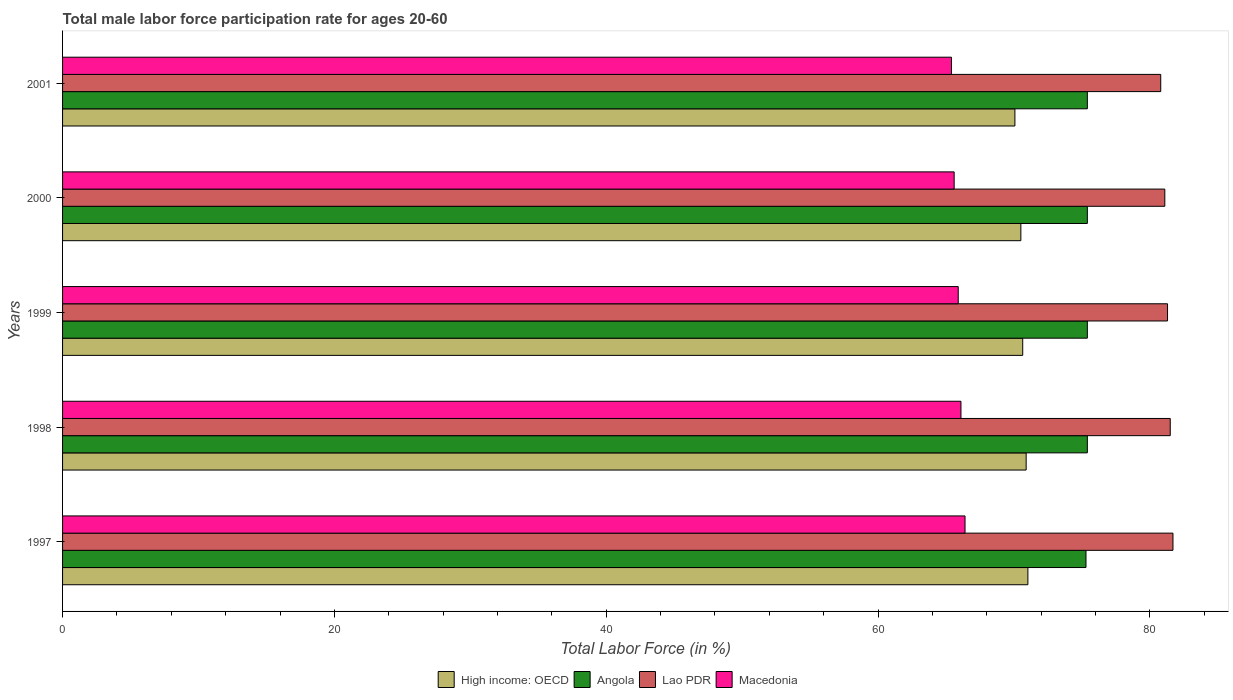How many different coloured bars are there?
Offer a terse response. 4. How many groups of bars are there?
Provide a short and direct response. 5. How many bars are there on the 4th tick from the top?
Provide a short and direct response. 4. What is the label of the 3rd group of bars from the top?
Ensure brevity in your answer.  1999. In how many cases, is the number of bars for a given year not equal to the number of legend labels?
Offer a very short reply. 0. What is the male labor force participation rate in High income: OECD in 2001?
Your answer should be compact. 70.07. Across all years, what is the maximum male labor force participation rate in Macedonia?
Your answer should be very brief. 66.4. Across all years, what is the minimum male labor force participation rate in Macedonia?
Keep it short and to the point. 65.4. In which year was the male labor force participation rate in Lao PDR maximum?
Provide a short and direct response. 1997. What is the total male labor force participation rate in Macedonia in the graph?
Make the answer very short. 329.4. What is the difference between the male labor force participation rate in Lao PDR in 1998 and that in 1999?
Your answer should be very brief. 0.2. What is the difference between the male labor force participation rate in Angola in 2000 and the male labor force participation rate in Macedonia in 1997?
Offer a very short reply. 9. What is the average male labor force participation rate in Macedonia per year?
Keep it short and to the point. 65.88. In the year 1999, what is the difference between the male labor force participation rate in High income: OECD and male labor force participation rate in Angola?
Make the answer very short. -4.76. In how many years, is the male labor force participation rate in Lao PDR greater than 68 %?
Offer a very short reply. 5. What is the ratio of the male labor force participation rate in Lao PDR in 1998 to that in 1999?
Offer a very short reply. 1. What is the difference between the highest and the second highest male labor force participation rate in High income: OECD?
Offer a terse response. 0.13. What is the difference between the highest and the lowest male labor force participation rate in Macedonia?
Make the answer very short. 1. In how many years, is the male labor force participation rate in Angola greater than the average male labor force participation rate in Angola taken over all years?
Provide a succinct answer. 4. What does the 4th bar from the top in 2000 represents?
Your answer should be compact. High income: OECD. What does the 3rd bar from the bottom in 1999 represents?
Keep it short and to the point. Lao PDR. How many bars are there?
Your answer should be very brief. 20. How many years are there in the graph?
Offer a terse response. 5. Are the values on the major ticks of X-axis written in scientific E-notation?
Your answer should be very brief. No. Does the graph contain grids?
Your answer should be compact. No. Where does the legend appear in the graph?
Keep it short and to the point. Bottom center. What is the title of the graph?
Your answer should be very brief. Total male labor force participation rate for ages 20-60. What is the label or title of the Y-axis?
Your response must be concise. Years. What is the Total Labor Force (in %) of High income: OECD in 1997?
Provide a short and direct response. 71.03. What is the Total Labor Force (in %) in Angola in 1997?
Your response must be concise. 75.3. What is the Total Labor Force (in %) in Lao PDR in 1997?
Provide a succinct answer. 81.7. What is the Total Labor Force (in %) of Macedonia in 1997?
Make the answer very short. 66.4. What is the Total Labor Force (in %) of High income: OECD in 1998?
Offer a terse response. 70.9. What is the Total Labor Force (in %) of Angola in 1998?
Offer a terse response. 75.4. What is the Total Labor Force (in %) of Lao PDR in 1998?
Ensure brevity in your answer.  81.5. What is the Total Labor Force (in %) of Macedonia in 1998?
Provide a short and direct response. 66.1. What is the Total Labor Force (in %) of High income: OECD in 1999?
Give a very brief answer. 70.64. What is the Total Labor Force (in %) of Angola in 1999?
Make the answer very short. 75.4. What is the Total Labor Force (in %) of Lao PDR in 1999?
Provide a succinct answer. 81.3. What is the Total Labor Force (in %) of Macedonia in 1999?
Provide a succinct answer. 65.9. What is the Total Labor Force (in %) in High income: OECD in 2000?
Provide a short and direct response. 70.51. What is the Total Labor Force (in %) in Angola in 2000?
Offer a very short reply. 75.4. What is the Total Labor Force (in %) of Lao PDR in 2000?
Your response must be concise. 81.1. What is the Total Labor Force (in %) in Macedonia in 2000?
Your answer should be very brief. 65.6. What is the Total Labor Force (in %) in High income: OECD in 2001?
Make the answer very short. 70.07. What is the Total Labor Force (in %) of Angola in 2001?
Provide a short and direct response. 75.4. What is the Total Labor Force (in %) in Lao PDR in 2001?
Give a very brief answer. 80.8. What is the Total Labor Force (in %) in Macedonia in 2001?
Provide a succinct answer. 65.4. Across all years, what is the maximum Total Labor Force (in %) of High income: OECD?
Keep it short and to the point. 71.03. Across all years, what is the maximum Total Labor Force (in %) in Angola?
Your response must be concise. 75.4. Across all years, what is the maximum Total Labor Force (in %) in Lao PDR?
Ensure brevity in your answer.  81.7. Across all years, what is the maximum Total Labor Force (in %) in Macedonia?
Make the answer very short. 66.4. Across all years, what is the minimum Total Labor Force (in %) in High income: OECD?
Your response must be concise. 70.07. Across all years, what is the minimum Total Labor Force (in %) of Angola?
Your response must be concise. 75.3. Across all years, what is the minimum Total Labor Force (in %) in Lao PDR?
Keep it short and to the point. 80.8. Across all years, what is the minimum Total Labor Force (in %) of Macedonia?
Provide a short and direct response. 65.4. What is the total Total Labor Force (in %) in High income: OECD in the graph?
Provide a succinct answer. 353.15. What is the total Total Labor Force (in %) of Angola in the graph?
Your answer should be very brief. 376.9. What is the total Total Labor Force (in %) of Lao PDR in the graph?
Ensure brevity in your answer.  406.4. What is the total Total Labor Force (in %) of Macedonia in the graph?
Provide a short and direct response. 329.4. What is the difference between the Total Labor Force (in %) in High income: OECD in 1997 and that in 1998?
Keep it short and to the point. 0.13. What is the difference between the Total Labor Force (in %) in Macedonia in 1997 and that in 1998?
Offer a terse response. 0.3. What is the difference between the Total Labor Force (in %) of High income: OECD in 1997 and that in 1999?
Keep it short and to the point. 0.38. What is the difference between the Total Labor Force (in %) in Macedonia in 1997 and that in 1999?
Offer a very short reply. 0.5. What is the difference between the Total Labor Force (in %) of High income: OECD in 1997 and that in 2000?
Make the answer very short. 0.52. What is the difference between the Total Labor Force (in %) of Angola in 1997 and that in 2000?
Your answer should be very brief. -0.1. What is the difference between the Total Labor Force (in %) of Lao PDR in 1997 and that in 2000?
Give a very brief answer. 0.6. What is the difference between the Total Labor Force (in %) in Macedonia in 1997 and that in 2000?
Ensure brevity in your answer.  0.8. What is the difference between the Total Labor Force (in %) of High income: OECD in 1997 and that in 2001?
Your response must be concise. 0.96. What is the difference between the Total Labor Force (in %) in Lao PDR in 1997 and that in 2001?
Your answer should be very brief. 0.9. What is the difference between the Total Labor Force (in %) in Macedonia in 1997 and that in 2001?
Provide a succinct answer. 1. What is the difference between the Total Labor Force (in %) in High income: OECD in 1998 and that in 1999?
Your answer should be compact. 0.25. What is the difference between the Total Labor Force (in %) in Angola in 1998 and that in 1999?
Offer a terse response. 0. What is the difference between the Total Labor Force (in %) of Lao PDR in 1998 and that in 1999?
Offer a very short reply. 0.2. What is the difference between the Total Labor Force (in %) of High income: OECD in 1998 and that in 2000?
Provide a succinct answer. 0.39. What is the difference between the Total Labor Force (in %) of Lao PDR in 1998 and that in 2000?
Provide a short and direct response. 0.4. What is the difference between the Total Labor Force (in %) in Macedonia in 1998 and that in 2000?
Give a very brief answer. 0.5. What is the difference between the Total Labor Force (in %) of High income: OECD in 1998 and that in 2001?
Keep it short and to the point. 0.83. What is the difference between the Total Labor Force (in %) in Lao PDR in 1998 and that in 2001?
Your answer should be compact. 0.7. What is the difference between the Total Labor Force (in %) in Macedonia in 1998 and that in 2001?
Give a very brief answer. 0.7. What is the difference between the Total Labor Force (in %) of High income: OECD in 1999 and that in 2000?
Provide a short and direct response. 0.14. What is the difference between the Total Labor Force (in %) of Angola in 1999 and that in 2000?
Your answer should be very brief. 0. What is the difference between the Total Labor Force (in %) of Macedonia in 1999 and that in 2000?
Offer a terse response. 0.3. What is the difference between the Total Labor Force (in %) of High income: OECD in 1999 and that in 2001?
Make the answer very short. 0.57. What is the difference between the Total Labor Force (in %) of Angola in 1999 and that in 2001?
Give a very brief answer. 0. What is the difference between the Total Labor Force (in %) of Lao PDR in 1999 and that in 2001?
Your answer should be compact. 0.5. What is the difference between the Total Labor Force (in %) in High income: OECD in 2000 and that in 2001?
Give a very brief answer. 0.44. What is the difference between the Total Labor Force (in %) of Angola in 2000 and that in 2001?
Ensure brevity in your answer.  0. What is the difference between the Total Labor Force (in %) of High income: OECD in 1997 and the Total Labor Force (in %) of Angola in 1998?
Keep it short and to the point. -4.37. What is the difference between the Total Labor Force (in %) of High income: OECD in 1997 and the Total Labor Force (in %) of Lao PDR in 1998?
Offer a terse response. -10.47. What is the difference between the Total Labor Force (in %) of High income: OECD in 1997 and the Total Labor Force (in %) of Macedonia in 1998?
Give a very brief answer. 4.93. What is the difference between the Total Labor Force (in %) of Angola in 1997 and the Total Labor Force (in %) of Lao PDR in 1998?
Keep it short and to the point. -6.2. What is the difference between the Total Labor Force (in %) of High income: OECD in 1997 and the Total Labor Force (in %) of Angola in 1999?
Ensure brevity in your answer.  -4.37. What is the difference between the Total Labor Force (in %) in High income: OECD in 1997 and the Total Labor Force (in %) in Lao PDR in 1999?
Ensure brevity in your answer.  -10.27. What is the difference between the Total Labor Force (in %) of High income: OECD in 1997 and the Total Labor Force (in %) of Macedonia in 1999?
Provide a succinct answer. 5.13. What is the difference between the Total Labor Force (in %) in Angola in 1997 and the Total Labor Force (in %) in Lao PDR in 1999?
Make the answer very short. -6. What is the difference between the Total Labor Force (in %) of Angola in 1997 and the Total Labor Force (in %) of Macedonia in 1999?
Offer a very short reply. 9.4. What is the difference between the Total Labor Force (in %) in High income: OECD in 1997 and the Total Labor Force (in %) in Angola in 2000?
Make the answer very short. -4.37. What is the difference between the Total Labor Force (in %) in High income: OECD in 1997 and the Total Labor Force (in %) in Lao PDR in 2000?
Provide a succinct answer. -10.07. What is the difference between the Total Labor Force (in %) in High income: OECD in 1997 and the Total Labor Force (in %) in Macedonia in 2000?
Provide a short and direct response. 5.43. What is the difference between the Total Labor Force (in %) in Angola in 1997 and the Total Labor Force (in %) in Macedonia in 2000?
Keep it short and to the point. 9.7. What is the difference between the Total Labor Force (in %) of High income: OECD in 1997 and the Total Labor Force (in %) of Angola in 2001?
Keep it short and to the point. -4.37. What is the difference between the Total Labor Force (in %) in High income: OECD in 1997 and the Total Labor Force (in %) in Lao PDR in 2001?
Ensure brevity in your answer.  -9.77. What is the difference between the Total Labor Force (in %) of High income: OECD in 1997 and the Total Labor Force (in %) of Macedonia in 2001?
Your response must be concise. 5.63. What is the difference between the Total Labor Force (in %) of Angola in 1997 and the Total Labor Force (in %) of Lao PDR in 2001?
Your response must be concise. -5.5. What is the difference between the Total Labor Force (in %) of Angola in 1997 and the Total Labor Force (in %) of Macedonia in 2001?
Make the answer very short. 9.9. What is the difference between the Total Labor Force (in %) of Lao PDR in 1997 and the Total Labor Force (in %) of Macedonia in 2001?
Offer a very short reply. 16.3. What is the difference between the Total Labor Force (in %) in High income: OECD in 1998 and the Total Labor Force (in %) in Angola in 1999?
Offer a terse response. -4.5. What is the difference between the Total Labor Force (in %) in High income: OECD in 1998 and the Total Labor Force (in %) in Lao PDR in 1999?
Offer a terse response. -10.4. What is the difference between the Total Labor Force (in %) in High income: OECD in 1998 and the Total Labor Force (in %) in Macedonia in 1999?
Ensure brevity in your answer.  5. What is the difference between the Total Labor Force (in %) in Angola in 1998 and the Total Labor Force (in %) in Lao PDR in 1999?
Provide a succinct answer. -5.9. What is the difference between the Total Labor Force (in %) of High income: OECD in 1998 and the Total Labor Force (in %) of Angola in 2000?
Provide a short and direct response. -4.5. What is the difference between the Total Labor Force (in %) in High income: OECD in 1998 and the Total Labor Force (in %) in Lao PDR in 2000?
Your answer should be compact. -10.2. What is the difference between the Total Labor Force (in %) in High income: OECD in 1998 and the Total Labor Force (in %) in Macedonia in 2000?
Provide a succinct answer. 5.3. What is the difference between the Total Labor Force (in %) of Angola in 1998 and the Total Labor Force (in %) of Lao PDR in 2000?
Your response must be concise. -5.7. What is the difference between the Total Labor Force (in %) of High income: OECD in 1998 and the Total Labor Force (in %) of Angola in 2001?
Provide a short and direct response. -4.5. What is the difference between the Total Labor Force (in %) in High income: OECD in 1998 and the Total Labor Force (in %) in Lao PDR in 2001?
Offer a very short reply. -9.9. What is the difference between the Total Labor Force (in %) in High income: OECD in 1998 and the Total Labor Force (in %) in Macedonia in 2001?
Your answer should be compact. 5.5. What is the difference between the Total Labor Force (in %) of Angola in 1998 and the Total Labor Force (in %) of Lao PDR in 2001?
Keep it short and to the point. -5.4. What is the difference between the Total Labor Force (in %) of Angola in 1998 and the Total Labor Force (in %) of Macedonia in 2001?
Your answer should be compact. 10. What is the difference between the Total Labor Force (in %) of High income: OECD in 1999 and the Total Labor Force (in %) of Angola in 2000?
Your answer should be compact. -4.76. What is the difference between the Total Labor Force (in %) in High income: OECD in 1999 and the Total Labor Force (in %) in Lao PDR in 2000?
Provide a short and direct response. -10.46. What is the difference between the Total Labor Force (in %) of High income: OECD in 1999 and the Total Labor Force (in %) of Macedonia in 2000?
Make the answer very short. 5.04. What is the difference between the Total Labor Force (in %) in Angola in 1999 and the Total Labor Force (in %) in Lao PDR in 2000?
Provide a succinct answer. -5.7. What is the difference between the Total Labor Force (in %) of Angola in 1999 and the Total Labor Force (in %) of Macedonia in 2000?
Keep it short and to the point. 9.8. What is the difference between the Total Labor Force (in %) of Lao PDR in 1999 and the Total Labor Force (in %) of Macedonia in 2000?
Ensure brevity in your answer.  15.7. What is the difference between the Total Labor Force (in %) of High income: OECD in 1999 and the Total Labor Force (in %) of Angola in 2001?
Ensure brevity in your answer.  -4.76. What is the difference between the Total Labor Force (in %) of High income: OECD in 1999 and the Total Labor Force (in %) of Lao PDR in 2001?
Keep it short and to the point. -10.16. What is the difference between the Total Labor Force (in %) in High income: OECD in 1999 and the Total Labor Force (in %) in Macedonia in 2001?
Offer a very short reply. 5.24. What is the difference between the Total Labor Force (in %) in High income: OECD in 2000 and the Total Labor Force (in %) in Angola in 2001?
Make the answer very short. -4.89. What is the difference between the Total Labor Force (in %) of High income: OECD in 2000 and the Total Labor Force (in %) of Lao PDR in 2001?
Give a very brief answer. -10.29. What is the difference between the Total Labor Force (in %) in High income: OECD in 2000 and the Total Labor Force (in %) in Macedonia in 2001?
Ensure brevity in your answer.  5.11. What is the difference between the Total Labor Force (in %) in Angola in 2000 and the Total Labor Force (in %) in Lao PDR in 2001?
Your answer should be very brief. -5.4. What is the difference between the Total Labor Force (in %) of Angola in 2000 and the Total Labor Force (in %) of Macedonia in 2001?
Give a very brief answer. 10. What is the average Total Labor Force (in %) in High income: OECD per year?
Provide a succinct answer. 70.63. What is the average Total Labor Force (in %) in Angola per year?
Offer a terse response. 75.38. What is the average Total Labor Force (in %) in Lao PDR per year?
Your response must be concise. 81.28. What is the average Total Labor Force (in %) in Macedonia per year?
Your response must be concise. 65.88. In the year 1997, what is the difference between the Total Labor Force (in %) in High income: OECD and Total Labor Force (in %) in Angola?
Make the answer very short. -4.27. In the year 1997, what is the difference between the Total Labor Force (in %) in High income: OECD and Total Labor Force (in %) in Lao PDR?
Offer a terse response. -10.67. In the year 1997, what is the difference between the Total Labor Force (in %) in High income: OECD and Total Labor Force (in %) in Macedonia?
Offer a very short reply. 4.63. In the year 1997, what is the difference between the Total Labor Force (in %) in Angola and Total Labor Force (in %) in Lao PDR?
Make the answer very short. -6.4. In the year 1997, what is the difference between the Total Labor Force (in %) of Angola and Total Labor Force (in %) of Macedonia?
Your answer should be compact. 8.9. In the year 1997, what is the difference between the Total Labor Force (in %) in Lao PDR and Total Labor Force (in %) in Macedonia?
Provide a succinct answer. 15.3. In the year 1998, what is the difference between the Total Labor Force (in %) of High income: OECD and Total Labor Force (in %) of Angola?
Offer a very short reply. -4.5. In the year 1998, what is the difference between the Total Labor Force (in %) in High income: OECD and Total Labor Force (in %) in Lao PDR?
Make the answer very short. -10.6. In the year 1998, what is the difference between the Total Labor Force (in %) in High income: OECD and Total Labor Force (in %) in Macedonia?
Provide a succinct answer. 4.8. In the year 1998, what is the difference between the Total Labor Force (in %) of Lao PDR and Total Labor Force (in %) of Macedonia?
Your response must be concise. 15.4. In the year 1999, what is the difference between the Total Labor Force (in %) of High income: OECD and Total Labor Force (in %) of Angola?
Ensure brevity in your answer.  -4.76. In the year 1999, what is the difference between the Total Labor Force (in %) in High income: OECD and Total Labor Force (in %) in Lao PDR?
Provide a succinct answer. -10.66. In the year 1999, what is the difference between the Total Labor Force (in %) of High income: OECD and Total Labor Force (in %) of Macedonia?
Provide a succinct answer. 4.74. In the year 1999, what is the difference between the Total Labor Force (in %) in Angola and Total Labor Force (in %) in Macedonia?
Your answer should be very brief. 9.5. In the year 2000, what is the difference between the Total Labor Force (in %) of High income: OECD and Total Labor Force (in %) of Angola?
Your answer should be compact. -4.89. In the year 2000, what is the difference between the Total Labor Force (in %) of High income: OECD and Total Labor Force (in %) of Lao PDR?
Give a very brief answer. -10.59. In the year 2000, what is the difference between the Total Labor Force (in %) in High income: OECD and Total Labor Force (in %) in Macedonia?
Your answer should be compact. 4.91. In the year 2000, what is the difference between the Total Labor Force (in %) of Angola and Total Labor Force (in %) of Lao PDR?
Provide a succinct answer. -5.7. In the year 2000, what is the difference between the Total Labor Force (in %) of Angola and Total Labor Force (in %) of Macedonia?
Give a very brief answer. 9.8. In the year 2000, what is the difference between the Total Labor Force (in %) in Lao PDR and Total Labor Force (in %) in Macedonia?
Offer a very short reply. 15.5. In the year 2001, what is the difference between the Total Labor Force (in %) of High income: OECD and Total Labor Force (in %) of Angola?
Keep it short and to the point. -5.33. In the year 2001, what is the difference between the Total Labor Force (in %) in High income: OECD and Total Labor Force (in %) in Lao PDR?
Ensure brevity in your answer.  -10.73. In the year 2001, what is the difference between the Total Labor Force (in %) of High income: OECD and Total Labor Force (in %) of Macedonia?
Make the answer very short. 4.67. In the year 2001, what is the difference between the Total Labor Force (in %) of Angola and Total Labor Force (in %) of Lao PDR?
Offer a very short reply. -5.4. In the year 2001, what is the difference between the Total Labor Force (in %) in Angola and Total Labor Force (in %) in Macedonia?
Offer a terse response. 10. What is the ratio of the Total Labor Force (in %) in High income: OECD in 1997 to that in 1998?
Offer a terse response. 1. What is the ratio of the Total Labor Force (in %) of High income: OECD in 1997 to that in 1999?
Your answer should be very brief. 1.01. What is the ratio of the Total Labor Force (in %) of Macedonia in 1997 to that in 1999?
Keep it short and to the point. 1.01. What is the ratio of the Total Labor Force (in %) in High income: OECD in 1997 to that in 2000?
Offer a terse response. 1.01. What is the ratio of the Total Labor Force (in %) in Angola in 1997 to that in 2000?
Keep it short and to the point. 1. What is the ratio of the Total Labor Force (in %) in Lao PDR in 1997 to that in 2000?
Offer a terse response. 1.01. What is the ratio of the Total Labor Force (in %) in Macedonia in 1997 to that in 2000?
Make the answer very short. 1.01. What is the ratio of the Total Labor Force (in %) in High income: OECD in 1997 to that in 2001?
Offer a terse response. 1.01. What is the ratio of the Total Labor Force (in %) in Lao PDR in 1997 to that in 2001?
Your answer should be compact. 1.01. What is the ratio of the Total Labor Force (in %) in Macedonia in 1997 to that in 2001?
Ensure brevity in your answer.  1.02. What is the ratio of the Total Labor Force (in %) in High income: OECD in 1998 to that in 1999?
Your answer should be very brief. 1. What is the ratio of the Total Labor Force (in %) of Lao PDR in 1998 to that in 1999?
Make the answer very short. 1. What is the ratio of the Total Labor Force (in %) in Lao PDR in 1998 to that in 2000?
Your answer should be compact. 1. What is the ratio of the Total Labor Force (in %) of Macedonia in 1998 to that in 2000?
Give a very brief answer. 1.01. What is the ratio of the Total Labor Force (in %) of High income: OECD in 1998 to that in 2001?
Make the answer very short. 1.01. What is the ratio of the Total Labor Force (in %) in Lao PDR in 1998 to that in 2001?
Your response must be concise. 1.01. What is the ratio of the Total Labor Force (in %) of Macedonia in 1998 to that in 2001?
Your response must be concise. 1.01. What is the ratio of the Total Labor Force (in %) of High income: OECD in 1999 to that in 2000?
Provide a succinct answer. 1. What is the ratio of the Total Labor Force (in %) in Lao PDR in 1999 to that in 2000?
Offer a very short reply. 1. What is the ratio of the Total Labor Force (in %) of High income: OECD in 1999 to that in 2001?
Your answer should be compact. 1.01. What is the ratio of the Total Labor Force (in %) in Angola in 1999 to that in 2001?
Offer a terse response. 1. What is the ratio of the Total Labor Force (in %) of Macedonia in 1999 to that in 2001?
Your answer should be very brief. 1.01. What is the ratio of the Total Labor Force (in %) in Angola in 2000 to that in 2001?
Provide a short and direct response. 1. What is the ratio of the Total Labor Force (in %) in Lao PDR in 2000 to that in 2001?
Keep it short and to the point. 1. What is the ratio of the Total Labor Force (in %) in Macedonia in 2000 to that in 2001?
Your response must be concise. 1. What is the difference between the highest and the second highest Total Labor Force (in %) in High income: OECD?
Make the answer very short. 0.13. What is the difference between the highest and the second highest Total Labor Force (in %) of Angola?
Give a very brief answer. 0. What is the difference between the highest and the lowest Total Labor Force (in %) in High income: OECD?
Give a very brief answer. 0.96. What is the difference between the highest and the lowest Total Labor Force (in %) in Angola?
Offer a terse response. 0.1. What is the difference between the highest and the lowest Total Labor Force (in %) of Lao PDR?
Make the answer very short. 0.9. 